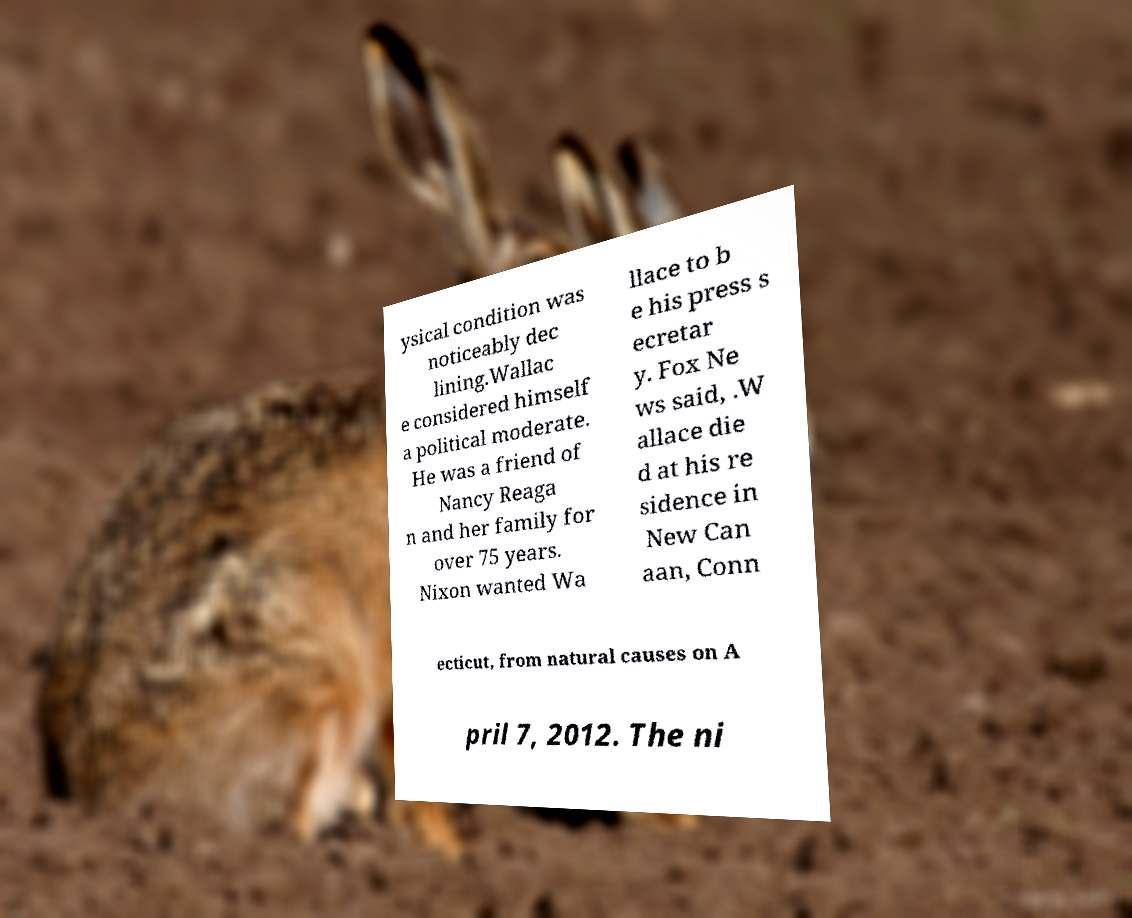Please read and relay the text visible in this image. What does it say? ysical condition was noticeably dec lining.Wallac e considered himself a political moderate. He was a friend of Nancy Reaga n and her family for over 75 years. Nixon wanted Wa llace to b e his press s ecretar y. Fox Ne ws said, .W allace die d at his re sidence in New Can aan, Conn ecticut, from natural causes on A pril 7, 2012. The ni 